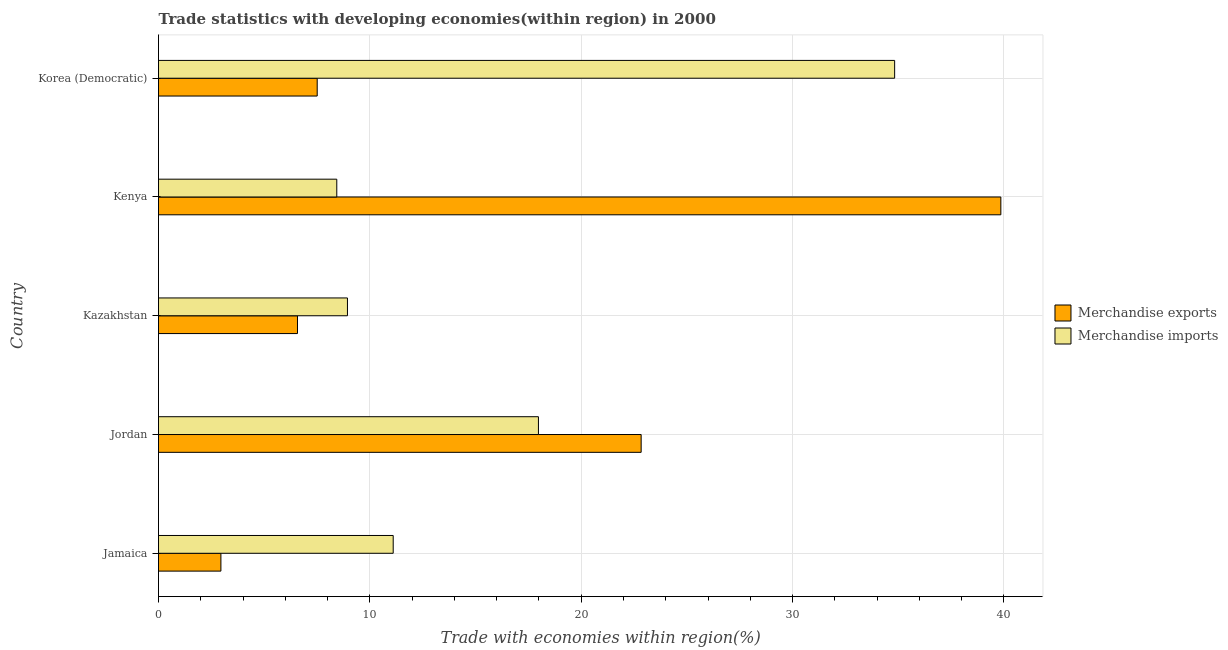How many groups of bars are there?
Provide a short and direct response. 5. How many bars are there on the 5th tick from the top?
Your response must be concise. 2. What is the label of the 2nd group of bars from the top?
Offer a terse response. Kenya. In how many cases, is the number of bars for a given country not equal to the number of legend labels?
Keep it short and to the point. 0. What is the merchandise imports in Kazakhstan?
Your answer should be very brief. 8.94. Across all countries, what is the maximum merchandise exports?
Make the answer very short. 39.85. Across all countries, what is the minimum merchandise exports?
Provide a short and direct response. 2.95. In which country was the merchandise exports maximum?
Offer a terse response. Kenya. In which country was the merchandise exports minimum?
Your answer should be compact. Jamaica. What is the total merchandise exports in the graph?
Provide a succinct answer. 79.73. What is the difference between the merchandise exports in Jordan and that in Kazakhstan?
Ensure brevity in your answer.  16.26. What is the difference between the merchandise exports in Kenya and the merchandise imports in Korea (Democratic)?
Your answer should be very brief. 5.02. What is the average merchandise imports per country?
Offer a terse response. 16.26. What is the difference between the merchandise exports and merchandise imports in Jordan?
Provide a succinct answer. 4.86. What is the ratio of the merchandise imports in Jordan to that in Kazakhstan?
Offer a terse response. 2.01. Is the merchandise imports in Jamaica less than that in Korea (Democratic)?
Offer a terse response. Yes. What is the difference between the highest and the second highest merchandise exports?
Give a very brief answer. 17.02. What is the difference between the highest and the lowest merchandise imports?
Your answer should be compact. 26.4. Is the sum of the merchandise exports in Kazakhstan and Korea (Democratic) greater than the maximum merchandise imports across all countries?
Your answer should be compact. No. How many bars are there?
Your answer should be very brief. 10. How many countries are there in the graph?
Provide a succinct answer. 5. What is the difference between two consecutive major ticks on the X-axis?
Provide a succinct answer. 10. Are the values on the major ticks of X-axis written in scientific E-notation?
Offer a terse response. No. Does the graph contain any zero values?
Give a very brief answer. No. Does the graph contain grids?
Your answer should be compact. Yes. What is the title of the graph?
Offer a very short reply. Trade statistics with developing economies(within region) in 2000. What is the label or title of the X-axis?
Give a very brief answer. Trade with economies within region(%). What is the label or title of the Y-axis?
Provide a short and direct response. Country. What is the Trade with economies within region(%) in Merchandise exports in Jamaica?
Keep it short and to the point. 2.95. What is the Trade with economies within region(%) in Merchandise imports in Jamaica?
Provide a short and direct response. 11.1. What is the Trade with economies within region(%) in Merchandise exports in Jordan?
Offer a very short reply. 22.84. What is the Trade with economies within region(%) of Merchandise imports in Jordan?
Offer a very short reply. 17.98. What is the Trade with economies within region(%) in Merchandise exports in Kazakhstan?
Ensure brevity in your answer.  6.57. What is the Trade with economies within region(%) in Merchandise imports in Kazakhstan?
Provide a succinct answer. 8.94. What is the Trade with economies within region(%) in Merchandise exports in Kenya?
Offer a very short reply. 39.85. What is the Trade with economies within region(%) in Merchandise imports in Kenya?
Your answer should be compact. 8.43. What is the Trade with economies within region(%) in Merchandise exports in Korea (Democratic)?
Your response must be concise. 7.51. What is the Trade with economies within region(%) of Merchandise imports in Korea (Democratic)?
Offer a very short reply. 34.83. Across all countries, what is the maximum Trade with economies within region(%) in Merchandise exports?
Your answer should be very brief. 39.85. Across all countries, what is the maximum Trade with economies within region(%) of Merchandise imports?
Ensure brevity in your answer.  34.83. Across all countries, what is the minimum Trade with economies within region(%) in Merchandise exports?
Offer a very short reply. 2.95. Across all countries, what is the minimum Trade with economies within region(%) of Merchandise imports?
Ensure brevity in your answer.  8.43. What is the total Trade with economies within region(%) of Merchandise exports in the graph?
Your response must be concise. 79.73. What is the total Trade with economies within region(%) of Merchandise imports in the graph?
Your response must be concise. 81.28. What is the difference between the Trade with economies within region(%) of Merchandise exports in Jamaica and that in Jordan?
Offer a very short reply. -19.88. What is the difference between the Trade with economies within region(%) in Merchandise imports in Jamaica and that in Jordan?
Offer a very short reply. -6.87. What is the difference between the Trade with economies within region(%) in Merchandise exports in Jamaica and that in Kazakhstan?
Make the answer very short. -3.62. What is the difference between the Trade with economies within region(%) of Merchandise imports in Jamaica and that in Kazakhstan?
Keep it short and to the point. 2.17. What is the difference between the Trade with economies within region(%) in Merchandise exports in Jamaica and that in Kenya?
Make the answer very short. -36.9. What is the difference between the Trade with economies within region(%) in Merchandise imports in Jamaica and that in Kenya?
Offer a very short reply. 2.67. What is the difference between the Trade with economies within region(%) of Merchandise exports in Jamaica and that in Korea (Democratic)?
Offer a very short reply. -4.56. What is the difference between the Trade with economies within region(%) of Merchandise imports in Jamaica and that in Korea (Democratic)?
Make the answer very short. -23.73. What is the difference between the Trade with economies within region(%) in Merchandise exports in Jordan and that in Kazakhstan?
Give a very brief answer. 16.26. What is the difference between the Trade with economies within region(%) in Merchandise imports in Jordan and that in Kazakhstan?
Your response must be concise. 9.04. What is the difference between the Trade with economies within region(%) of Merchandise exports in Jordan and that in Kenya?
Provide a short and direct response. -17.02. What is the difference between the Trade with economies within region(%) of Merchandise imports in Jordan and that in Kenya?
Offer a very short reply. 9.54. What is the difference between the Trade with economies within region(%) of Merchandise exports in Jordan and that in Korea (Democratic)?
Your answer should be very brief. 15.33. What is the difference between the Trade with economies within region(%) in Merchandise imports in Jordan and that in Korea (Democratic)?
Offer a very short reply. -16.85. What is the difference between the Trade with economies within region(%) in Merchandise exports in Kazakhstan and that in Kenya?
Provide a succinct answer. -33.28. What is the difference between the Trade with economies within region(%) in Merchandise imports in Kazakhstan and that in Kenya?
Provide a short and direct response. 0.5. What is the difference between the Trade with economies within region(%) in Merchandise exports in Kazakhstan and that in Korea (Democratic)?
Make the answer very short. -0.93. What is the difference between the Trade with economies within region(%) of Merchandise imports in Kazakhstan and that in Korea (Democratic)?
Provide a short and direct response. -25.89. What is the difference between the Trade with economies within region(%) in Merchandise exports in Kenya and that in Korea (Democratic)?
Give a very brief answer. 32.35. What is the difference between the Trade with economies within region(%) of Merchandise imports in Kenya and that in Korea (Democratic)?
Offer a very short reply. -26.4. What is the difference between the Trade with economies within region(%) of Merchandise exports in Jamaica and the Trade with economies within region(%) of Merchandise imports in Jordan?
Your response must be concise. -15.02. What is the difference between the Trade with economies within region(%) in Merchandise exports in Jamaica and the Trade with economies within region(%) in Merchandise imports in Kazakhstan?
Make the answer very short. -5.99. What is the difference between the Trade with economies within region(%) in Merchandise exports in Jamaica and the Trade with economies within region(%) in Merchandise imports in Kenya?
Keep it short and to the point. -5.48. What is the difference between the Trade with economies within region(%) in Merchandise exports in Jamaica and the Trade with economies within region(%) in Merchandise imports in Korea (Democratic)?
Ensure brevity in your answer.  -31.88. What is the difference between the Trade with economies within region(%) in Merchandise exports in Jordan and the Trade with economies within region(%) in Merchandise imports in Kazakhstan?
Ensure brevity in your answer.  13.9. What is the difference between the Trade with economies within region(%) of Merchandise exports in Jordan and the Trade with economies within region(%) of Merchandise imports in Kenya?
Your answer should be very brief. 14.4. What is the difference between the Trade with economies within region(%) in Merchandise exports in Jordan and the Trade with economies within region(%) in Merchandise imports in Korea (Democratic)?
Offer a terse response. -11.99. What is the difference between the Trade with economies within region(%) in Merchandise exports in Kazakhstan and the Trade with economies within region(%) in Merchandise imports in Kenya?
Offer a very short reply. -1.86. What is the difference between the Trade with economies within region(%) of Merchandise exports in Kazakhstan and the Trade with economies within region(%) of Merchandise imports in Korea (Democratic)?
Offer a terse response. -28.25. What is the difference between the Trade with economies within region(%) of Merchandise exports in Kenya and the Trade with economies within region(%) of Merchandise imports in Korea (Democratic)?
Your answer should be very brief. 5.02. What is the average Trade with economies within region(%) in Merchandise exports per country?
Offer a terse response. 15.95. What is the average Trade with economies within region(%) of Merchandise imports per country?
Offer a terse response. 16.26. What is the difference between the Trade with economies within region(%) of Merchandise exports and Trade with economies within region(%) of Merchandise imports in Jamaica?
Provide a short and direct response. -8.15. What is the difference between the Trade with economies within region(%) of Merchandise exports and Trade with economies within region(%) of Merchandise imports in Jordan?
Your response must be concise. 4.86. What is the difference between the Trade with economies within region(%) in Merchandise exports and Trade with economies within region(%) in Merchandise imports in Kazakhstan?
Provide a short and direct response. -2.36. What is the difference between the Trade with economies within region(%) of Merchandise exports and Trade with economies within region(%) of Merchandise imports in Kenya?
Offer a very short reply. 31.42. What is the difference between the Trade with economies within region(%) in Merchandise exports and Trade with economies within region(%) in Merchandise imports in Korea (Democratic)?
Provide a short and direct response. -27.32. What is the ratio of the Trade with economies within region(%) in Merchandise exports in Jamaica to that in Jordan?
Give a very brief answer. 0.13. What is the ratio of the Trade with economies within region(%) in Merchandise imports in Jamaica to that in Jordan?
Provide a succinct answer. 0.62. What is the ratio of the Trade with economies within region(%) in Merchandise exports in Jamaica to that in Kazakhstan?
Your answer should be compact. 0.45. What is the ratio of the Trade with economies within region(%) of Merchandise imports in Jamaica to that in Kazakhstan?
Keep it short and to the point. 1.24. What is the ratio of the Trade with economies within region(%) of Merchandise exports in Jamaica to that in Kenya?
Your response must be concise. 0.07. What is the ratio of the Trade with economies within region(%) in Merchandise imports in Jamaica to that in Kenya?
Provide a short and direct response. 1.32. What is the ratio of the Trade with economies within region(%) of Merchandise exports in Jamaica to that in Korea (Democratic)?
Give a very brief answer. 0.39. What is the ratio of the Trade with economies within region(%) of Merchandise imports in Jamaica to that in Korea (Democratic)?
Provide a short and direct response. 0.32. What is the ratio of the Trade with economies within region(%) of Merchandise exports in Jordan to that in Kazakhstan?
Keep it short and to the point. 3.47. What is the ratio of the Trade with economies within region(%) in Merchandise imports in Jordan to that in Kazakhstan?
Give a very brief answer. 2.01. What is the ratio of the Trade with economies within region(%) in Merchandise exports in Jordan to that in Kenya?
Keep it short and to the point. 0.57. What is the ratio of the Trade with economies within region(%) of Merchandise imports in Jordan to that in Kenya?
Provide a succinct answer. 2.13. What is the ratio of the Trade with economies within region(%) of Merchandise exports in Jordan to that in Korea (Democratic)?
Your answer should be compact. 3.04. What is the ratio of the Trade with economies within region(%) in Merchandise imports in Jordan to that in Korea (Democratic)?
Keep it short and to the point. 0.52. What is the ratio of the Trade with economies within region(%) in Merchandise exports in Kazakhstan to that in Kenya?
Give a very brief answer. 0.17. What is the ratio of the Trade with economies within region(%) of Merchandise imports in Kazakhstan to that in Kenya?
Provide a short and direct response. 1.06. What is the ratio of the Trade with economies within region(%) of Merchandise exports in Kazakhstan to that in Korea (Democratic)?
Ensure brevity in your answer.  0.88. What is the ratio of the Trade with economies within region(%) in Merchandise imports in Kazakhstan to that in Korea (Democratic)?
Keep it short and to the point. 0.26. What is the ratio of the Trade with economies within region(%) in Merchandise exports in Kenya to that in Korea (Democratic)?
Keep it short and to the point. 5.31. What is the ratio of the Trade with economies within region(%) in Merchandise imports in Kenya to that in Korea (Democratic)?
Ensure brevity in your answer.  0.24. What is the difference between the highest and the second highest Trade with economies within region(%) in Merchandise exports?
Your answer should be very brief. 17.02. What is the difference between the highest and the second highest Trade with economies within region(%) of Merchandise imports?
Keep it short and to the point. 16.85. What is the difference between the highest and the lowest Trade with economies within region(%) of Merchandise exports?
Provide a short and direct response. 36.9. What is the difference between the highest and the lowest Trade with economies within region(%) of Merchandise imports?
Your response must be concise. 26.4. 